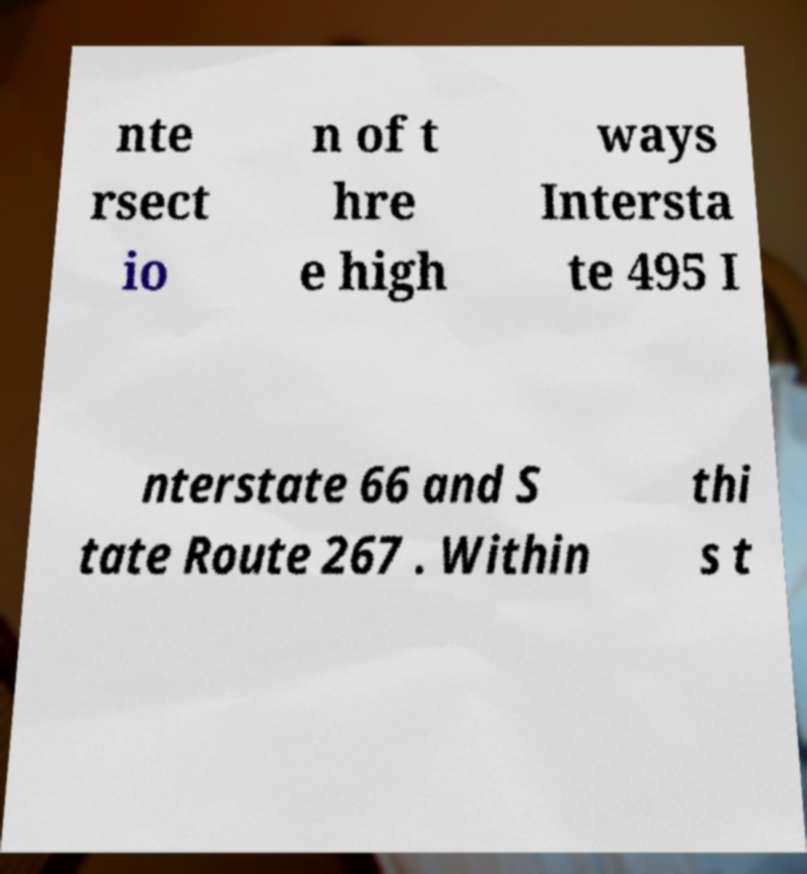Could you extract and type out the text from this image? nte rsect io n of t hre e high ways Intersta te 495 I nterstate 66 and S tate Route 267 . Within thi s t 